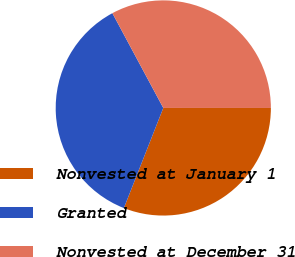<chart> <loc_0><loc_0><loc_500><loc_500><pie_chart><fcel>Nonvested at January 1<fcel>Granted<fcel>Nonvested at December 31<nl><fcel>30.97%<fcel>36.19%<fcel>32.85%<nl></chart> 